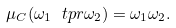<formula> <loc_0><loc_0><loc_500><loc_500>\mu _ { C } ( \omega _ { 1 } \ t p r \omega _ { 2 } ) = \omega _ { 1 } \omega _ { 2 } .</formula> 